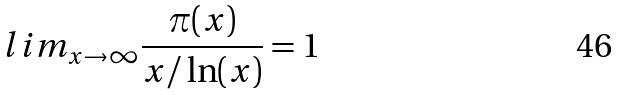<formula> <loc_0><loc_0><loc_500><loc_500>l i m _ { x \rightarrow \infty } \frac { \pi ( x ) } { x / \ln ( x ) } = 1</formula> 